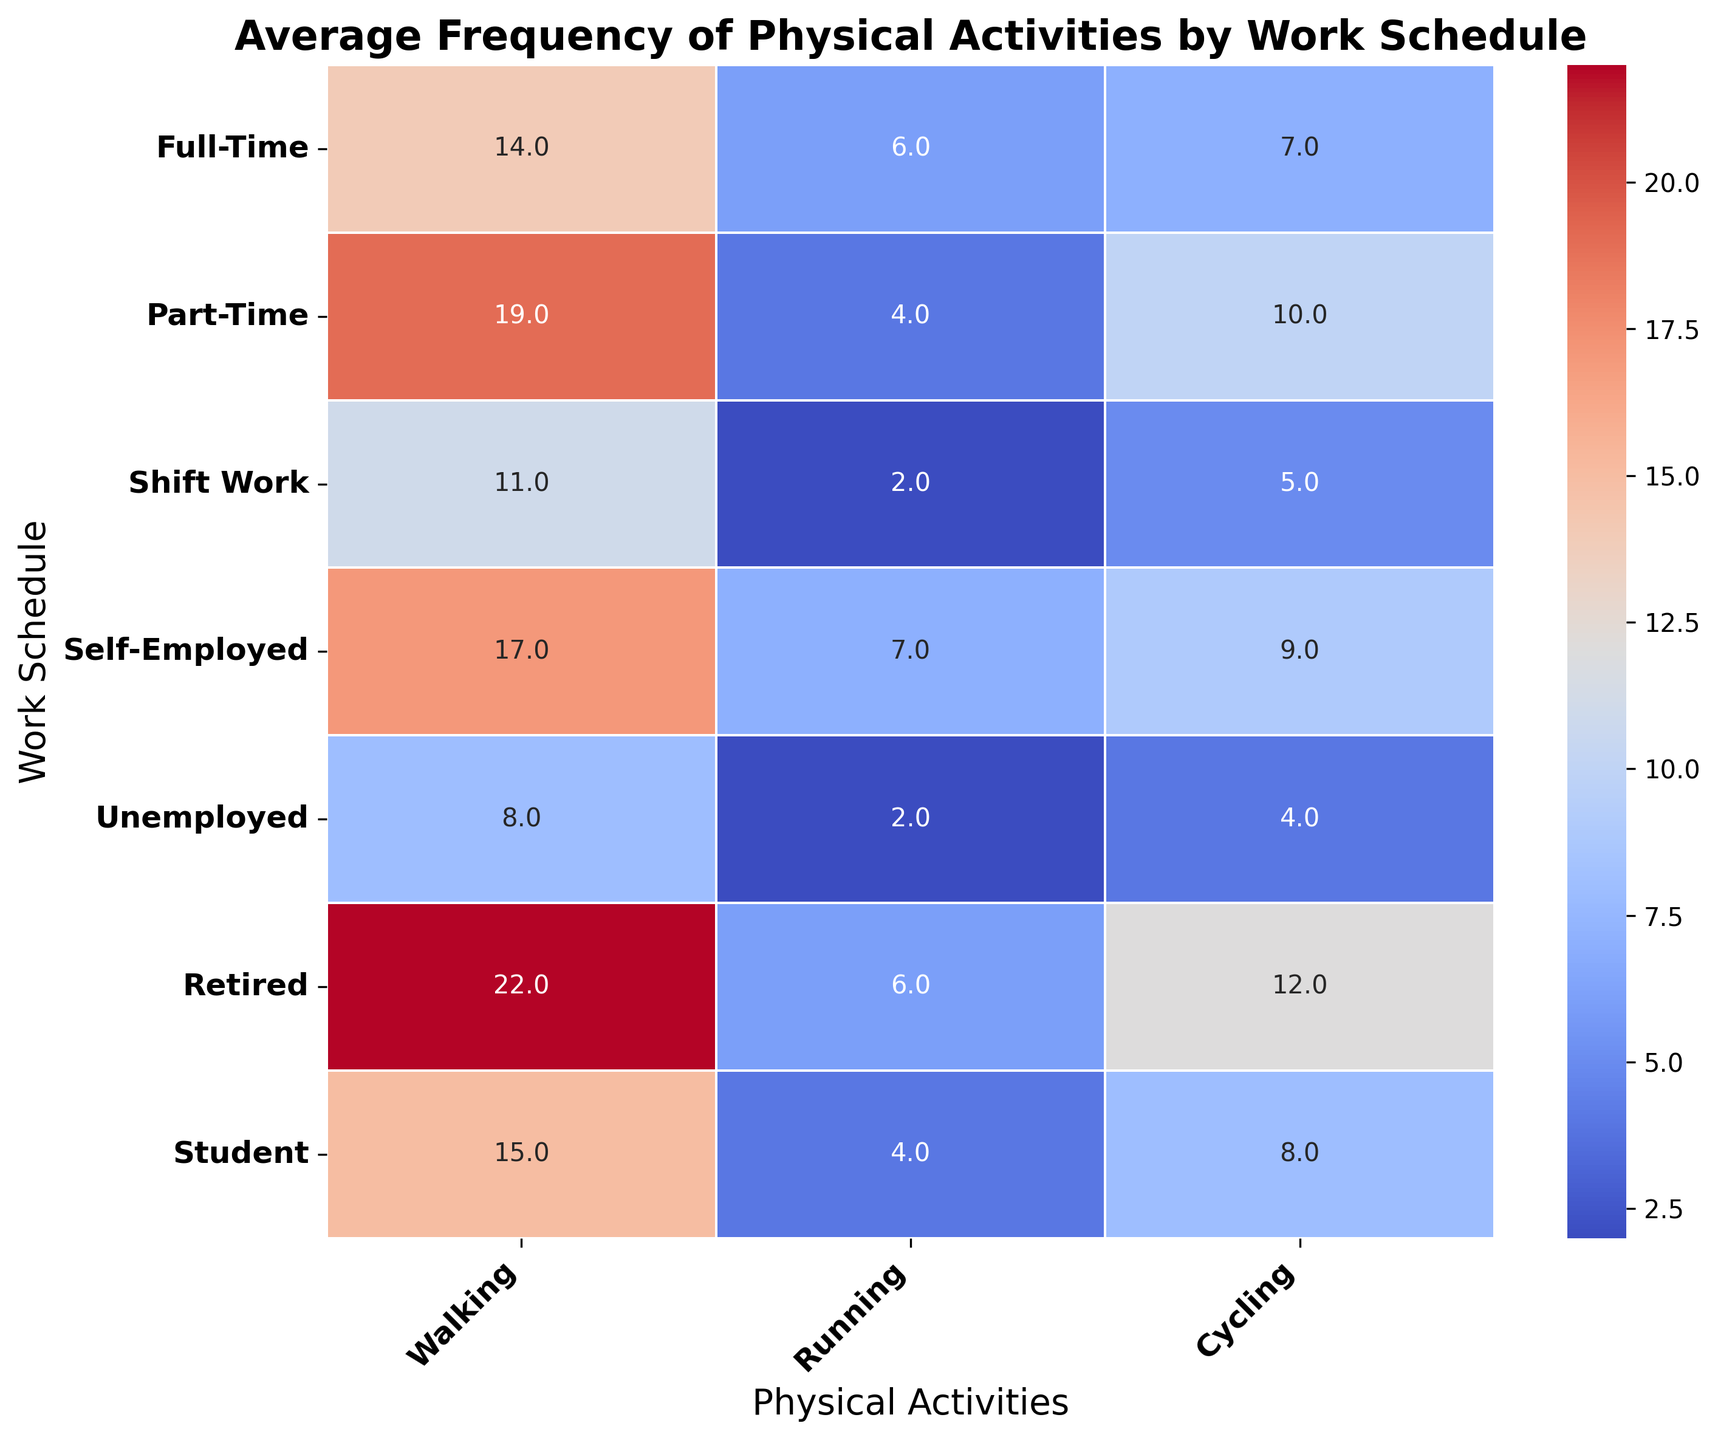Which work schedule has the highest frequency of walking? The heatmap shows that the darkest box in the "Walking" column corresponds to the "Retired" row, indicating that retired residents engage in walking the most frequently.
Answer: Retired What is the average frequency of running for full-time and part-time workers combined? The average frequencies of running for full-time and part-time workers are 6.0 and 4.0, respectively. Adding these gives 6.0 + 4.0 = 10.0, then dividing by 2 gives 10.0 / 2 = 5.0
Answer: 5.0 Which work schedule has the lowest frequency of cycling? The heatmap shows that the lightest box in the "Cycling" column corresponds to the "Unemployed" row, indicating that unemployed residents engage in cycling the least frequently.
Answer: Unemployed How does the frequency of walking for shift workers compare to that for students? The heatmap indicates that the average frequency of walking for shift workers is 11.0, while for students, it is 15.0. Therefore, students walk more frequently than shift workers.
Answer: Students walk more frequently Among running activities, which two work schedules have similar frequencies and what are they? The heatmap shows that the frequencies of running for "Full-Time" and "Self-Employed" are 6.0 and 7.0, respectively, which are quite similar.
Answer: Full-Time and Self-Employed (6.0 and 7.0) What is the difference in the frequency of cycling between unemployed and retired residents? The heatmap shows that the average frequency of cycling is 4.0 for unemployed residents and 12.0 for retired residents. The difference is 12.0 - 4.0 = 8.0
Answer: 8.0 Which work schedule sees the highest overall frequency of physical activities combined (sum of walking, running, and cycling)? Summing the frequencies for each activity for each work schedule and comparing them: 
Full-Time: 14.0 + 6.0 + 7.0 = 27.0 
Part-Time: 19.0 + 4.0 + 10.0 = 33.0 
Shift Work: 11.0 + 2.0 + 5.0 = 18.0 
Self-Employed: 17.0 + 7.0 + 9.0 = 33.0 
Unemployed: 8.0 + 2.0 + 4.0 = 14.0 
Retired: 22.0 + 6.0 + 12.0 = 40.0 
Student: 15.0 + 4.0 + 8.0 = 27.0 
The highest combined frequency is for retired residents.
Answer: Retired 